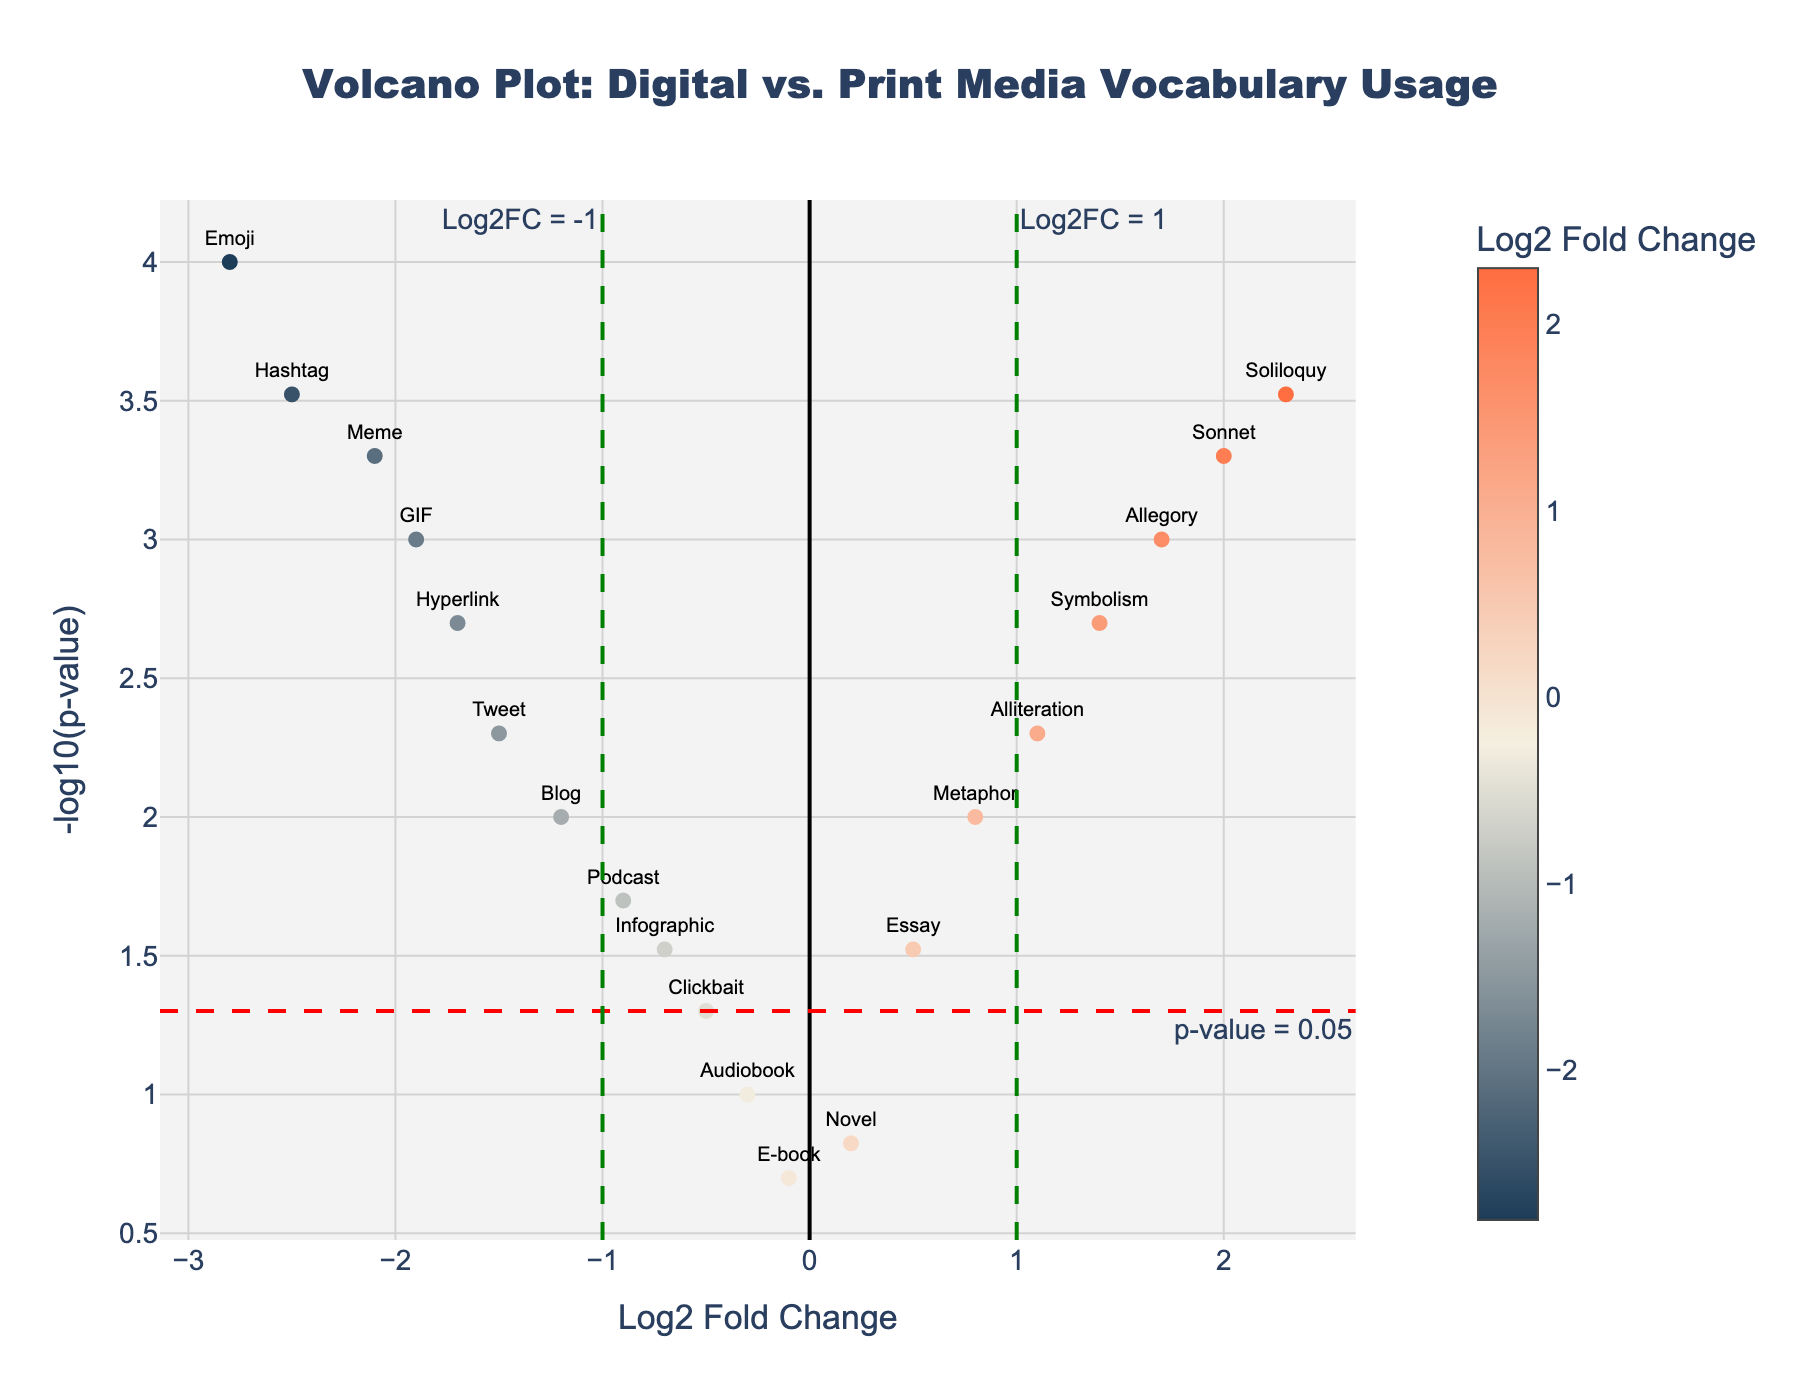What is the title of the figure? The title is displayed at the top center of the figure. It reads, "Volcano Plot: Digital vs. Print Media Vocabulary Usage".
Answer: Volcano Plot: Digital vs. Print Media Vocabulary Usage How many words are significantly different at a p-value threshold of 0.05? In a Volcano Plot, words above the horizontal red dashed line, which represents the -log10(0.05) threshold, are significant. Count the words above this line.
Answer: 14 words Which word has the highest Log2FoldChange? The highest Log2FoldChange is found by locating the data point farthest to the right on the x-axis. This word is marked "Soliloquy" with a Log2FoldChange of 2.3.
Answer: Soliloquy What is the Log2FoldChange and p-value for "Emoji"? Locate "Emoji" on the plot. The hover information shows Log2FoldChange and p-value for each point. For "Emoji", Log2FoldChange is -2.8 and p-value is 0.0001.
Answer: Log2FoldChange: -2.8, p-value: 0.0001 Are there any words with a Log2FoldChange between -0.5 and 0.5? Identify words within the range -0.5 < Log2FoldChange < 0.5 by examining the points along the x-axis. Words within this range have Log2FoldChanges between -0.3 to 0.2.
Answer: Yes, "Audiobook", "E-book", and "Novel" Which word has the lowest p-value, and what is its Log2FoldChange? The lowest p-value corresponds to the highest -log10(p-value) on the y-axis. "Emoji" has the highest -log10(p-value), indicating the lowest p-value (0.0001). Its Log2FoldChange is -2.8.
Answer: Emoji, Log2FoldChange: -2.8 Compare the word "Sonnet" with "Soliloquy". Which has a higher p-value? Locate "Sonnet" and "Soliloquy" on the plot. The hover details show the p-values. "Sonnet" has a p-value of 0.0005 and "Soliloquy" has 0.0003, so "Sonnet" has a higher p-value.
Answer: Sonnet What is the range of Log2FoldChange for words associated with digital media? Identify words related to digital media ("Emoji", "Hashtag", "Meme", "GIF", "Hyperlink", "Tweet", "Blog", "Podcast", "Infographic", "Clickbait", "Audiobook", "E-book"). Check their Log2FoldChange values. The range is from -2.8 ("Emoji") to -0.1 ("E-book").
Answer: -2.8 to -0.1 How many words have a Log2FoldChange greater than 1? Locate words with Log2FoldChange values greater than 1 by examining the right side of the x-axis. These words are "Symbolism", "Allegory", "Sonnet", and "Soliloquy".
Answer: 4 words What insight can be derived about the usage of traditional literary devices in digital vs. print media? Traditional literary devices ("Metaphor", "Alliteration", "Symbolism", "Allegory", "Sonnet", "Soliloquy") are all on the right side of the plot with positive Log2FoldChange, indicating higher usage in print media compared to digital media.
Answer: Higher usage in print media 